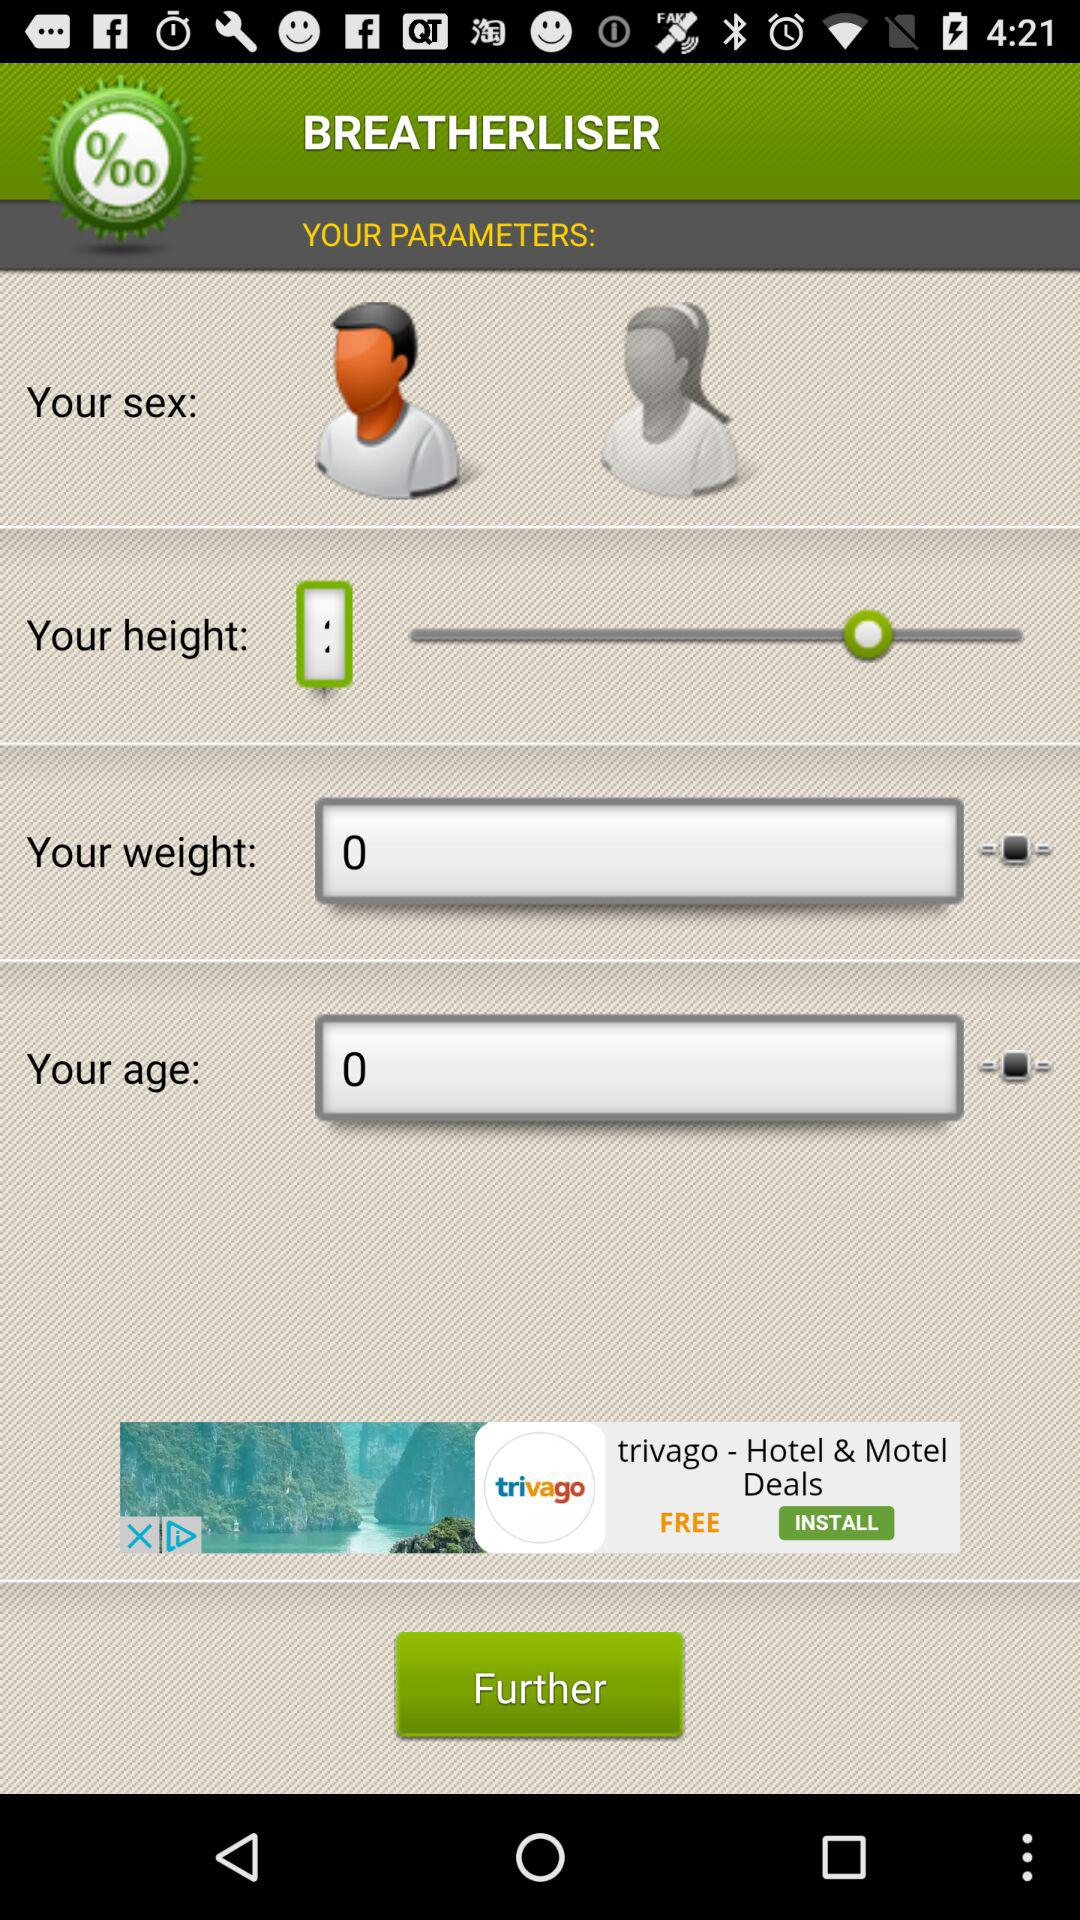What is the value entered in the weight bar? The value entered in the weight bar is 0. 